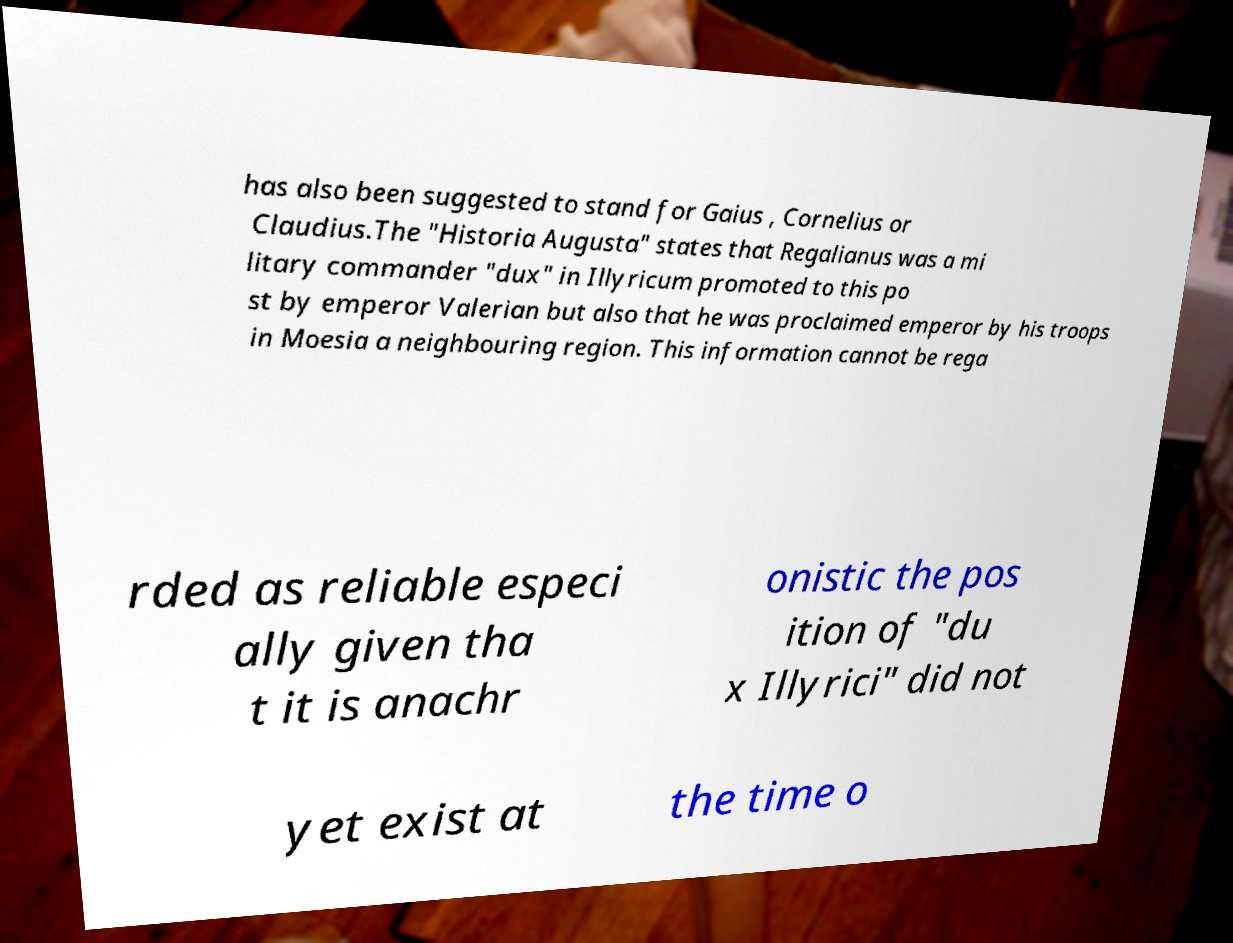For documentation purposes, I need the text within this image transcribed. Could you provide that? has also been suggested to stand for Gaius , Cornelius or Claudius.The "Historia Augusta" states that Regalianus was a mi litary commander "dux" in Illyricum promoted to this po st by emperor Valerian but also that he was proclaimed emperor by his troops in Moesia a neighbouring region. This information cannot be rega rded as reliable especi ally given tha t it is anachr onistic the pos ition of "du x Illyrici" did not yet exist at the time o 